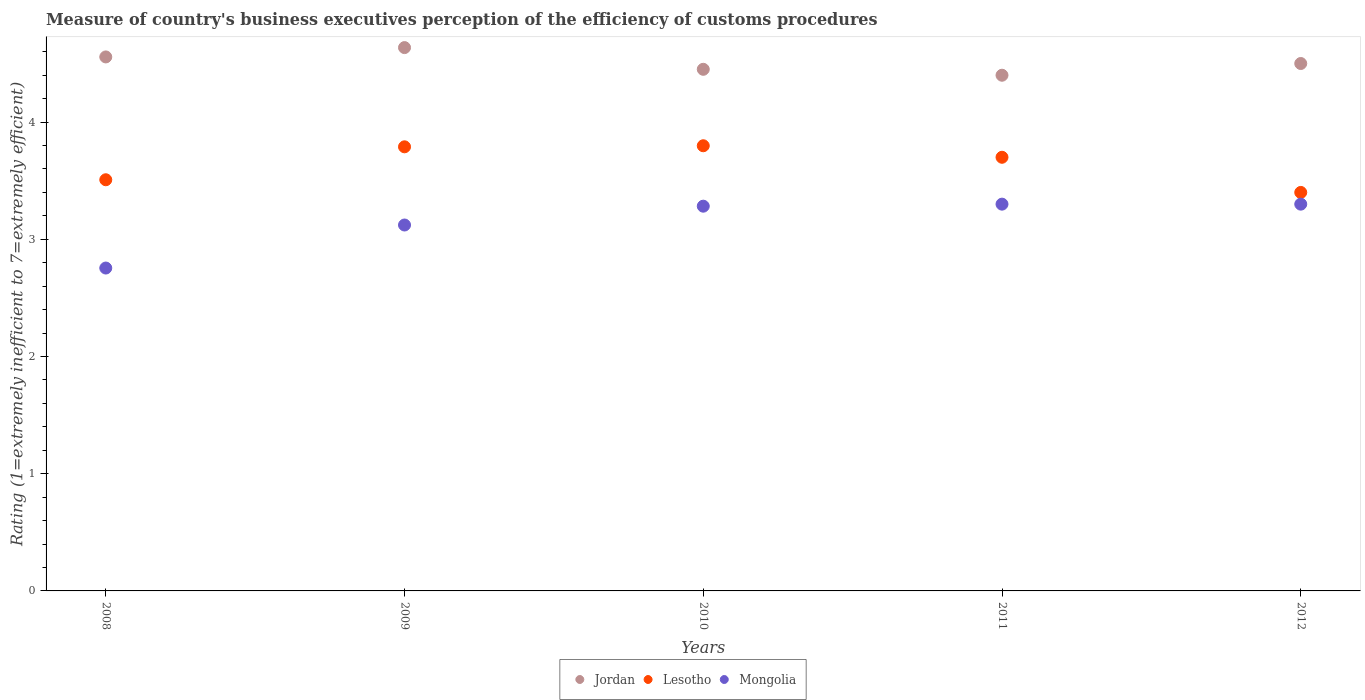Is the number of dotlines equal to the number of legend labels?
Ensure brevity in your answer.  Yes. What is the rating of the efficiency of customs procedure in Jordan in 2009?
Keep it short and to the point. 4.64. Across all years, what is the maximum rating of the efficiency of customs procedure in Jordan?
Provide a short and direct response. 4.64. Across all years, what is the minimum rating of the efficiency of customs procedure in Lesotho?
Provide a succinct answer. 3.4. In which year was the rating of the efficiency of customs procedure in Jordan minimum?
Give a very brief answer. 2011. What is the total rating of the efficiency of customs procedure in Jordan in the graph?
Keep it short and to the point. 22.54. What is the difference between the rating of the efficiency of customs procedure in Jordan in 2008 and that in 2010?
Give a very brief answer. 0.11. What is the difference between the rating of the efficiency of customs procedure in Mongolia in 2011 and the rating of the efficiency of customs procedure in Jordan in 2008?
Provide a succinct answer. -1.26. What is the average rating of the efficiency of customs procedure in Lesotho per year?
Offer a terse response. 3.64. In the year 2011, what is the difference between the rating of the efficiency of customs procedure in Mongolia and rating of the efficiency of customs procedure in Lesotho?
Offer a very short reply. -0.4. What is the ratio of the rating of the efficiency of customs procedure in Jordan in 2011 to that in 2012?
Offer a very short reply. 0.98. Is the rating of the efficiency of customs procedure in Lesotho in 2008 less than that in 2010?
Provide a short and direct response. Yes. Is the difference between the rating of the efficiency of customs procedure in Mongolia in 2008 and 2010 greater than the difference between the rating of the efficiency of customs procedure in Lesotho in 2008 and 2010?
Keep it short and to the point. No. What is the difference between the highest and the second highest rating of the efficiency of customs procedure in Jordan?
Your response must be concise. 0.08. What is the difference between the highest and the lowest rating of the efficiency of customs procedure in Mongolia?
Ensure brevity in your answer.  0.55. Is it the case that in every year, the sum of the rating of the efficiency of customs procedure in Mongolia and rating of the efficiency of customs procedure in Lesotho  is greater than the rating of the efficiency of customs procedure in Jordan?
Provide a short and direct response. Yes. Does the rating of the efficiency of customs procedure in Mongolia monotonically increase over the years?
Provide a succinct answer. No. Is the rating of the efficiency of customs procedure in Lesotho strictly greater than the rating of the efficiency of customs procedure in Jordan over the years?
Provide a short and direct response. No. Is the rating of the efficiency of customs procedure in Mongolia strictly less than the rating of the efficiency of customs procedure in Jordan over the years?
Offer a terse response. Yes. Does the graph contain any zero values?
Give a very brief answer. No. Where does the legend appear in the graph?
Your answer should be compact. Bottom center. How are the legend labels stacked?
Provide a short and direct response. Horizontal. What is the title of the graph?
Keep it short and to the point. Measure of country's business executives perception of the efficiency of customs procedures. Does "Aruba" appear as one of the legend labels in the graph?
Your answer should be very brief. No. What is the label or title of the X-axis?
Ensure brevity in your answer.  Years. What is the label or title of the Y-axis?
Your response must be concise. Rating (1=extremely inefficient to 7=extremely efficient). What is the Rating (1=extremely inefficient to 7=extremely efficient) of Jordan in 2008?
Your response must be concise. 4.56. What is the Rating (1=extremely inefficient to 7=extremely efficient) in Lesotho in 2008?
Your answer should be very brief. 3.51. What is the Rating (1=extremely inefficient to 7=extremely efficient) in Mongolia in 2008?
Make the answer very short. 2.75. What is the Rating (1=extremely inefficient to 7=extremely efficient) in Jordan in 2009?
Your response must be concise. 4.64. What is the Rating (1=extremely inefficient to 7=extremely efficient) in Lesotho in 2009?
Offer a terse response. 3.79. What is the Rating (1=extremely inefficient to 7=extremely efficient) in Mongolia in 2009?
Make the answer very short. 3.12. What is the Rating (1=extremely inefficient to 7=extremely efficient) in Jordan in 2010?
Ensure brevity in your answer.  4.45. What is the Rating (1=extremely inefficient to 7=extremely efficient) in Lesotho in 2010?
Your response must be concise. 3.8. What is the Rating (1=extremely inefficient to 7=extremely efficient) in Mongolia in 2010?
Your response must be concise. 3.28. What is the Rating (1=extremely inefficient to 7=extremely efficient) of Jordan in 2011?
Offer a terse response. 4.4. What is the Rating (1=extremely inefficient to 7=extremely efficient) of Lesotho in 2011?
Offer a terse response. 3.7. What is the Rating (1=extremely inefficient to 7=extremely efficient) in Mongolia in 2011?
Your response must be concise. 3.3. What is the Rating (1=extremely inefficient to 7=extremely efficient) in Lesotho in 2012?
Give a very brief answer. 3.4. Across all years, what is the maximum Rating (1=extremely inefficient to 7=extremely efficient) of Jordan?
Offer a very short reply. 4.64. Across all years, what is the maximum Rating (1=extremely inefficient to 7=extremely efficient) of Lesotho?
Provide a short and direct response. 3.8. Across all years, what is the minimum Rating (1=extremely inefficient to 7=extremely efficient) of Lesotho?
Make the answer very short. 3.4. Across all years, what is the minimum Rating (1=extremely inefficient to 7=extremely efficient) of Mongolia?
Provide a succinct answer. 2.75. What is the total Rating (1=extremely inefficient to 7=extremely efficient) in Jordan in the graph?
Provide a succinct answer. 22.54. What is the total Rating (1=extremely inefficient to 7=extremely efficient) of Lesotho in the graph?
Make the answer very short. 18.2. What is the total Rating (1=extremely inefficient to 7=extremely efficient) in Mongolia in the graph?
Make the answer very short. 15.76. What is the difference between the Rating (1=extremely inefficient to 7=extremely efficient) of Jordan in 2008 and that in 2009?
Offer a terse response. -0.08. What is the difference between the Rating (1=extremely inefficient to 7=extremely efficient) in Lesotho in 2008 and that in 2009?
Give a very brief answer. -0.28. What is the difference between the Rating (1=extremely inefficient to 7=extremely efficient) of Mongolia in 2008 and that in 2009?
Ensure brevity in your answer.  -0.37. What is the difference between the Rating (1=extremely inefficient to 7=extremely efficient) in Jordan in 2008 and that in 2010?
Offer a very short reply. 0.11. What is the difference between the Rating (1=extremely inefficient to 7=extremely efficient) in Lesotho in 2008 and that in 2010?
Your answer should be compact. -0.29. What is the difference between the Rating (1=extremely inefficient to 7=extremely efficient) of Mongolia in 2008 and that in 2010?
Your answer should be very brief. -0.53. What is the difference between the Rating (1=extremely inefficient to 7=extremely efficient) in Jordan in 2008 and that in 2011?
Your response must be concise. 0.16. What is the difference between the Rating (1=extremely inefficient to 7=extremely efficient) of Lesotho in 2008 and that in 2011?
Ensure brevity in your answer.  -0.19. What is the difference between the Rating (1=extremely inefficient to 7=extremely efficient) of Mongolia in 2008 and that in 2011?
Provide a short and direct response. -0.55. What is the difference between the Rating (1=extremely inefficient to 7=extremely efficient) in Jordan in 2008 and that in 2012?
Give a very brief answer. 0.06. What is the difference between the Rating (1=extremely inefficient to 7=extremely efficient) in Lesotho in 2008 and that in 2012?
Make the answer very short. 0.11. What is the difference between the Rating (1=extremely inefficient to 7=extremely efficient) of Mongolia in 2008 and that in 2012?
Your response must be concise. -0.55. What is the difference between the Rating (1=extremely inefficient to 7=extremely efficient) in Jordan in 2009 and that in 2010?
Your answer should be very brief. 0.19. What is the difference between the Rating (1=extremely inefficient to 7=extremely efficient) in Lesotho in 2009 and that in 2010?
Provide a succinct answer. -0.01. What is the difference between the Rating (1=extremely inefficient to 7=extremely efficient) of Mongolia in 2009 and that in 2010?
Ensure brevity in your answer.  -0.16. What is the difference between the Rating (1=extremely inefficient to 7=extremely efficient) of Jordan in 2009 and that in 2011?
Your response must be concise. 0.24. What is the difference between the Rating (1=extremely inefficient to 7=extremely efficient) in Lesotho in 2009 and that in 2011?
Offer a very short reply. 0.09. What is the difference between the Rating (1=extremely inefficient to 7=extremely efficient) of Mongolia in 2009 and that in 2011?
Give a very brief answer. -0.18. What is the difference between the Rating (1=extremely inefficient to 7=extremely efficient) in Jordan in 2009 and that in 2012?
Ensure brevity in your answer.  0.14. What is the difference between the Rating (1=extremely inefficient to 7=extremely efficient) in Lesotho in 2009 and that in 2012?
Offer a terse response. 0.39. What is the difference between the Rating (1=extremely inefficient to 7=extremely efficient) of Mongolia in 2009 and that in 2012?
Give a very brief answer. -0.18. What is the difference between the Rating (1=extremely inefficient to 7=extremely efficient) in Jordan in 2010 and that in 2011?
Give a very brief answer. 0.05. What is the difference between the Rating (1=extremely inefficient to 7=extremely efficient) in Lesotho in 2010 and that in 2011?
Your answer should be compact. 0.1. What is the difference between the Rating (1=extremely inefficient to 7=extremely efficient) in Mongolia in 2010 and that in 2011?
Make the answer very short. -0.02. What is the difference between the Rating (1=extremely inefficient to 7=extremely efficient) in Jordan in 2010 and that in 2012?
Offer a terse response. -0.05. What is the difference between the Rating (1=extremely inefficient to 7=extremely efficient) in Lesotho in 2010 and that in 2012?
Provide a short and direct response. 0.4. What is the difference between the Rating (1=extremely inefficient to 7=extremely efficient) of Mongolia in 2010 and that in 2012?
Keep it short and to the point. -0.02. What is the difference between the Rating (1=extremely inefficient to 7=extremely efficient) in Lesotho in 2011 and that in 2012?
Your answer should be very brief. 0.3. What is the difference between the Rating (1=extremely inefficient to 7=extremely efficient) in Jordan in 2008 and the Rating (1=extremely inefficient to 7=extremely efficient) in Lesotho in 2009?
Your answer should be very brief. 0.77. What is the difference between the Rating (1=extremely inefficient to 7=extremely efficient) of Jordan in 2008 and the Rating (1=extremely inefficient to 7=extremely efficient) of Mongolia in 2009?
Make the answer very short. 1.43. What is the difference between the Rating (1=extremely inefficient to 7=extremely efficient) of Lesotho in 2008 and the Rating (1=extremely inefficient to 7=extremely efficient) of Mongolia in 2009?
Your answer should be compact. 0.39. What is the difference between the Rating (1=extremely inefficient to 7=extremely efficient) in Jordan in 2008 and the Rating (1=extremely inefficient to 7=extremely efficient) in Lesotho in 2010?
Give a very brief answer. 0.76. What is the difference between the Rating (1=extremely inefficient to 7=extremely efficient) of Jordan in 2008 and the Rating (1=extremely inefficient to 7=extremely efficient) of Mongolia in 2010?
Make the answer very short. 1.27. What is the difference between the Rating (1=extremely inefficient to 7=extremely efficient) in Lesotho in 2008 and the Rating (1=extremely inefficient to 7=extremely efficient) in Mongolia in 2010?
Provide a short and direct response. 0.23. What is the difference between the Rating (1=extremely inefficient to 7=extremely efficient) in Jordan in 2008 and the Rating (1=extremely inefficient to 7=extremely efficient) in Lesotho in 2011?
Provide a succinct answer. 0.86. What is the difference between the Rating (1=extremely inefficient to 7=extremely efficient) of Jordan in 2008 and the Rating (1=extremely inefficient to 7=extremely efficient) of Mongolia in 2011?
Provide a succinct answer. 1.26. What is the difference between the Rating (1=extremely inefficient to 7=extremely efficient) of Lesotho in 2008 and the Rating (1=extremely inefficient to 7=extremely efficient) of Mongolia in 2011?
Your answer should be very brief. 0.21. What is the difference between the Rating (1=extremely inefficient to 7=extremely efficient) in Jordan in 2008 and the Rating (1=extremely inefficient to 7=extremely efficient) in Lesotho in 2012?
Offer a terse response. 1.16. What is the difference between the Rating (1=extremely inefficient to 7=extremely efficient) of Jordan in 2008 and the Rating (1=extremely inefficient to 7=extremely efficient) of Mongolia in 2012?
Offer a terse response. 1.26. What is the difference between the Rating (1=extremely inefficient to 7=extremely efficient) in Lesotho in 2008 and the Rating (1=extremely inefficient to 7=extremely efficient) in Mongolia in 2012?
Your response must be concise. 0.21. What is the difference between the Rating (1=extremely inefficient to 7=extremely efficient) in Jordan in 2009 and the Rating (1=extremely inefficient to 7=extremely efficient) in Lesotho in 2010?
Offer a very short reply. 0.84. What is the difference between the Rating (1=extremely inefficient to 7=extremely efficient) in Jordan in 2009 and the Rating (1=extremely inefficient to 7=extremely efficient) in Mongolia in 2010?
Keep it short and to the point. 1.35. What is the difference between the Rating (1=extremely inefficient to 7=extremely efficient) of Lesotho in 2009 and the Rating (1=extremely inefficient to 7=extremely efficient) of Mongolia in 2010?
Offer a very short reply. 0.51. What is the difference between the Rating (1=extremely inefficient to 7=extremely efficient) in Jordan in 2009 and the Rating (1=extremely inefficient to 7=extremely efficient) in Lesotho in 2011?
Your response must be concise. 0.94. What is the difference between the Rating (1=extremely inefficient to 7=extremely efficient) of Jordan in 2009 and the Rating (1=extremely inefficient to 7=extremely efficient) of Mongolia in 2011?
Offer a terse response. 1.34. What is the difference between the Rating (1=extremely inefficient to 7=extremely efficient) of Lesotho in 2009 and the Rating (1=extremely inefficient to 7=extremely efficient) of Mongolia in 2011?
Ensure brevity in your answer.  0.49. What is the difference between the Rating (1=extremely inefficient to 7=extremely efficient) of Jordan in 2009 and the Rating (1=extremely inefficient to 7=extremely efficient) of Lesotho in 2012?
Ensure brevity in your answer.  1.24. What is the difference between the Rating (1=extremely inefficient to 7=extremely efficient) of Jordan in 2009 and the Rating (1=extremely inefficient to 7=extremely efficient) of Mongolia in 2012?
Provide a succinct answer. 1.34. What is the difference between the Rating (1=extremely inefficient to 7=extremely efficient) in Lesotho in 2009 and the Rating (1=extremely inefficient to 7=extremely efficient) in Mongolia in 2012?
Provide a succinct answer. 0.49. What is the difference between the Rating (1=extremely inefficient to 7=extremely efficient) in Jordan in 2010 and the Rating (1=extremely inefficient to 7=extremely efficient) in Lesotho in 2011?
Keep it short and to the point. 0.75. What is the difference between the Rating (1=extremely inefficient to 7=extremely efficient) in Jordan in 2010 and the Rating (1=extremely inefficient to 7=extremely efficient) in Mongolia in 2011?
Provide a succinct answer. 1.15. What is the difference between the Rating (1=extremely inefficient to 7=extremely efficient) in Lesotho in 2010 and the Rating (1=extremely inefficient to 7=extremely efficient) in Mongolia in 2011?
Offer a terse response. 0.5. What is the difference between the Rating (1=extremely inefficient to 7=extremely efficient) in Jordan in 2010 and the Rating (1=extremely inefficient to 7=extremely efficient) in Lesotho in 2012?
Give a very brief answer. 1.05. What is the difference between the Rating (1=extremely inefficient to 7=extremely efficient) of Jordan in 2010 and the Rating (1=extremely inefficient to 7=extremely efficient) of Mongolia in 2012?
Offer a terse response. 1.15. What is the difference between the Rating (1=extremely inefficient to 7=extremely efficient) of Lesotho in 2010 and the Rating (1=extremely inefficient to 7=extremely efficient) of Mongolia in 2012?
Your answer should be very brief. 0.5. What is the difference between the Rating (1=extremely inefficient to 7=extremely efficient) in Jordan in 2011 and the Rating (1=extremely inefficient to 7=extremely efficient) in Lesotho in 2012?
Ensure brevity in your answer.  1. What is the difference between the Rating (1=extremely inefficient to 7=extremely efficient) in Lesotho in 2011 and the Rating (1=extremely inefficient to 7=extremely efficient) in Mongolia in 2012?
Ensure brevity in your answer.  0.4. What is the average Rating (1=extremely inefficient to 7=extremely efficient) of Jordan per year?
Offer a very short reply. 4.51. What is the average Rating (1=extremely inefficient to 7=extremely efficient) in Lesotho per year?
Your response must be concise. 3.64. What is the average Rating (1=extremely inefficient to 7=extremely efficient) of Mongolia per year?
Your answer should be very brief. 3.15. In the year 2008, what is the difference between the Rating (1=extremely inefficient to 7=extremely efficient) in Jordan and Rating (1=extremely inefficient to 7=extremely efficient) in Lesotho?
Offer a very short reply. 1.05. In the year 2008, what is the difference between the Rating (1=extremely inefficient to 7=extremely efficient) in Jordan and Rating (1=extremely inefficient to 7=extremely efficient) in Mongolia?
Keep it short and to the point. 1.8. In the year 2008, what is the difference between the Rating (1=extremely inefficient to 7=extremely efficient) in Lesotho and Rating (1=extremely inefficient to 7=extremely efficient) in Mongolia?
Offer a terse response. 0.75. In the year 2009, what is the difference between the Rating (1=extremely inefficient to 7=extremely efficient) of Jordan and Rating (1=extremely inefficient to 7=extremely efficient) of Lesotho?
Offer a very short reply. 0.85. In the year 2009, what is the difference between the Rating (1=extremely inefficient to 7=extremely efficient) in Jordan and Rating (1=extremely inefficient to 7=extremely efficient) in Mongolia?
Your answer should be very brief. 1.51. In the year 2009, what is the difference between the Rating (1=extremely inefficient to 7=extremely efficient) of Lesotho and Rating (1=extremely inefficient to 7=extremely efficient) of Mongolia?
Provide a succinct answer. 0.67. In the year 2010, what is the difference between the Rating (1=extremely inefficient to 7=extremely efficient) in Jordan and Rating (1=extremely inefficient to 7=extremely efficient) in Lesotho?
Keep it short and to the point. 0.65. In the year 2010, what is the difference between the Rating (1=extremely inefficient to 7=extremely efficient) of Jordan and Rating (1=extremely inefficient to 7=extremely efficient) of Mongolia?
Keep it short and to the point. 1.17. In the year 2010, what is the difference between the Rating (1=extremely inefficient to 7=extremely efficient) of Lesotho and Rating (1=extremely inefficient to 7=extremely efficient) of Mongolia?
Your response must be concise. 0.52. In the year 2011, what is the difference between the Rating (1=extremely inefficient to 7=extremely efficient) in Lesotho and Rating (1=extremely inefficient to 7=extremely efficient) in Mongolia?
Offer a very short reply. 0.4. In the year 2012, what is the difference between the Rating (1=extremely inefficient to 7=extremely efficient) of Jordan and Rating (1=extremely inefficient to 7=extremely efficient) of Mongolia?
Give a very brief answer. 1.2. In the year 2012, what is the difference between the Rating (1=extremely inefficient to 7=extremely efficient) in Lesotho and Rating (1=extremely inefficient to 7=extremely efficient) in Mongolia?
Offer a very short reply. 0.1. What is the ratio of the Rating (1=extremely inefficient to 7=extremely efficient) in Jordan in 2008 to that in 2009?
Offer a very short reply. 0.98. What is the ratio of the Rating (1=extremely inefficient to 7=extremely efficient) of Lesotho in 2008 to that in 2009?
Your response must be concise. 0.93. What is the ratio of the Rating (1=extremely inefficient to 7=extremely efficient) of Mongolia in 2008 to that in 2009?
Keep it short and to the point. 0.88. What is the ratio of the Rating (1=extremely inefficient to 7=extremely efficient) of Jordan in 2008 to that in 2010?
Keep it short and to the point. 1.02. What is the ratio of the Rating (1=extremely inefficient to 7=extremely efficient) in Lesotho in 2008 to that in 2010?
Offer a terse response. 0.92. What is the ratio of the Rating (1=extremely inefficient to 7=extremely efficient) in Mongolia in 2008 to that in 2010?
Make the answer very short. 0.84. What is the ratio of the Rating (1=extremely inefficient to 7=extremely efficient) of Jordan in 2008 to that in 2011?
Offer a very short reply. 1.04. What is the ratio of the Rating (1=extremely inefficient to 7=extremely efficient) in Lesotho in 2008 to that in 2011?
Your answer should be compact. 0.95. What is the ratio of the Rating (1=extremely inefficient to 7=extremely efficient) of Mongolia in 2008 to that in 2011?
Ensure brevity in your answer.  0.83. What is the ratio of the Rating (1=extremely inefficient to 7=extremely efficient) of Jordan in 2008 to that in 2012?
Ensure brevity in your answer.  1.01. What is the ratio of the Rating (1=extremely inefficient to 7=extremely efficient) in Lesotho in 2008 to that in 2012?
Make the answer very short. 1.03. What is the ratio of the Rating (1=extremely inefficient to 7=extremely efficient) in Mongolia in 2008 to that in 2012?
Your answer should be very brief. 0.83. What is the ratio of the Rating (1=extremely inefficient to 7=extremely efficient) in Jordan in 2009 to that in 2010?
Provide a succinct answer. 1.04. What is the ratio of the Rating (1=extremely inefficient to 7=extremely efficient) of Lesotho in 2009 to that in 2010?
Provide a short and direct response. 1. What is the ratio of the Rating (1=extremely inefficient to 7=extremely efficient) in Mongolia in 2009 to that in 2010?
Your answer should be very brief. 0.95. What is the ratio of the Rating (1=extremely inefficient to 7=extremely efficient) in Jordan in 2009 to that in 2011?
Provide a short and direct response. 1.05. What is the ratio of the Rating (1=extremely inefficient to 7=extremely efficient) in Lesotho in 2009 to that in 2011?
Offer a very short reply. 1.02. What is the ratio of the Rating (1=extremely inefficient to 7=extremely efficient) of Mongolia in 2009 to that in 2011?
Make the answer very short. 0.95. What is the ratio of the Rating (1=extremely inefficient to 7=extremely efficient) in Jordan in 2009 to that in 2012?
Offer a terse response. 1.03. What is the ratio of the Rating (1=extremely inefficient to 7=extremely efficient) in Lesotho in 2009 to that in 2012?
Offer a terse response. 1.11. What is the ratio of the Rating (1=extremely inefficient to 7=extremely efficient) of Mongolia in 2009 to that in 2012?
Your answer should be compact. 0.95. What is the ratio of the Rating (1=extremely inefficient to 7=extremely efficient) of Jordan in 2010 to that in 2011?
Ensure brevity in your answer.  1.01. What is the ratio of the Rating (1=extremely inefficient to 7=extremely efficient) of Lesotho in 2010 to that in 2011?
Give a very brief answer. 1.03. What is the ratio of the Rating (1=extremely inefficient to 7=extremely efficient) in Mongolia in 2010 to that in 2011?
Your answer should be compact. 0.99. What is the ratio of the Rating (1=extremely inefficient to 7=extremely efficient) of Lesotho in 2010 to that in 2012?
Offer a very short reply. 1.12. What is the ratio of the Rating (1=extremely inefficient to 7=extremely efficient) in Jordan in 2011 to that in 2012?
Your answer should be very brief. 0.98. What is the ratio of the Rating (1=extremely inefficient to 7=extremely efficient) of Lesotho in 2011 to that in 2012?
Offer a very short reply. 1.09. What is the difference between the highest and the second highest Rating (1=extremely inefficient to 7=extremely efficient) in Jordan?
Your answer should be very brief. 0.08. What is the difference between the highest and the second highest Rating (1=extremely inefficient to 7=extremely efficient) in Lesotho?
Ensure brevity in your answer.  0.01. What is the difference between the highest and the lowest Rating (1=extremely inefficient to 7=extremely efficient) of Jordan?
Offer a terse response. 0.24. What is the difference between the highest and the lowest Rating (1=extremely inefficient to 7=extremely efficient) of Lesotho?
Give a very brief answer. 0.4. What is the difference between the highest and the lowest Rating (1=extremely inefficient to 7=extremely efficient) of Mongolia?
Offer a very short reply. 0.55. 